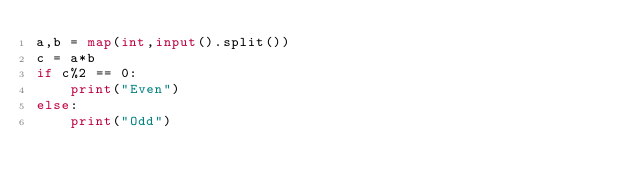<code> <loc_0><loc_0><loc_500><loc_500><_Python_>a,b = map(int,input().split())
c = a*b
if c%2 == 0:
    print("Even")
else:
    print("Odd")
</code> 